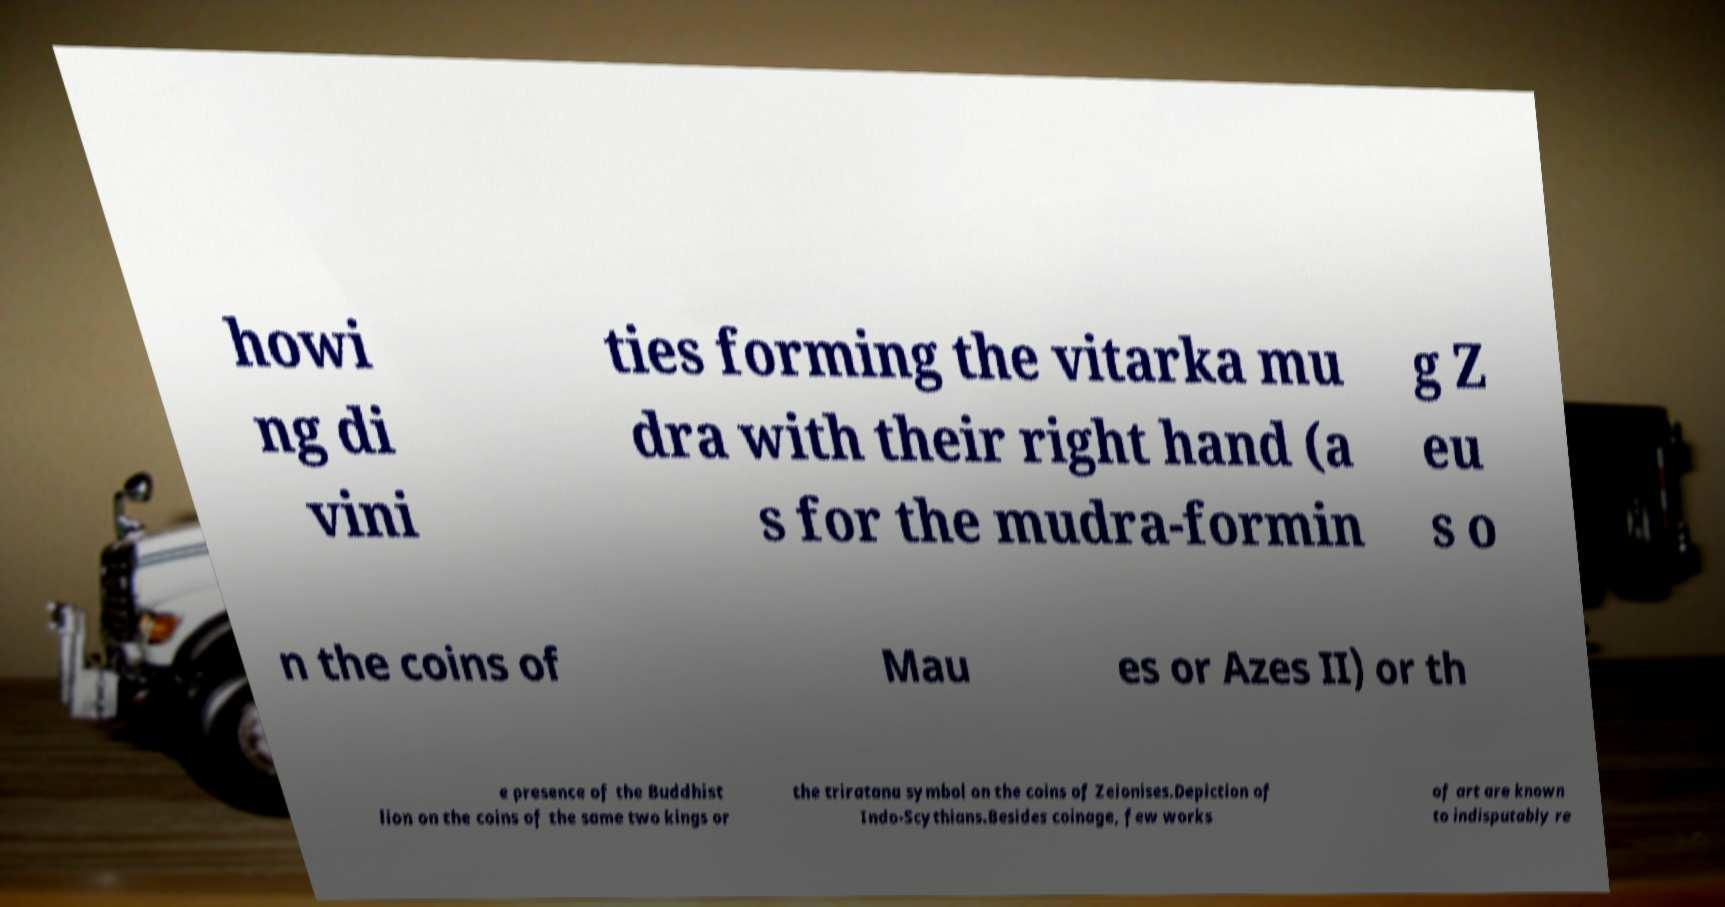Please identify and transcribe the text found in this image. howi ng di vini ties forming the vitarka mu dra with their right hand (a s for the mudra-formin g Z eu s o n the coins of Mau es or Azes II) or th e presence of the Buddhist lion on the coins of the same two kings or the triratana symbol on the coins of Zeionises.Depiction of Indo-Scythians.Besides coinage, few works of art are known to indisputably re 